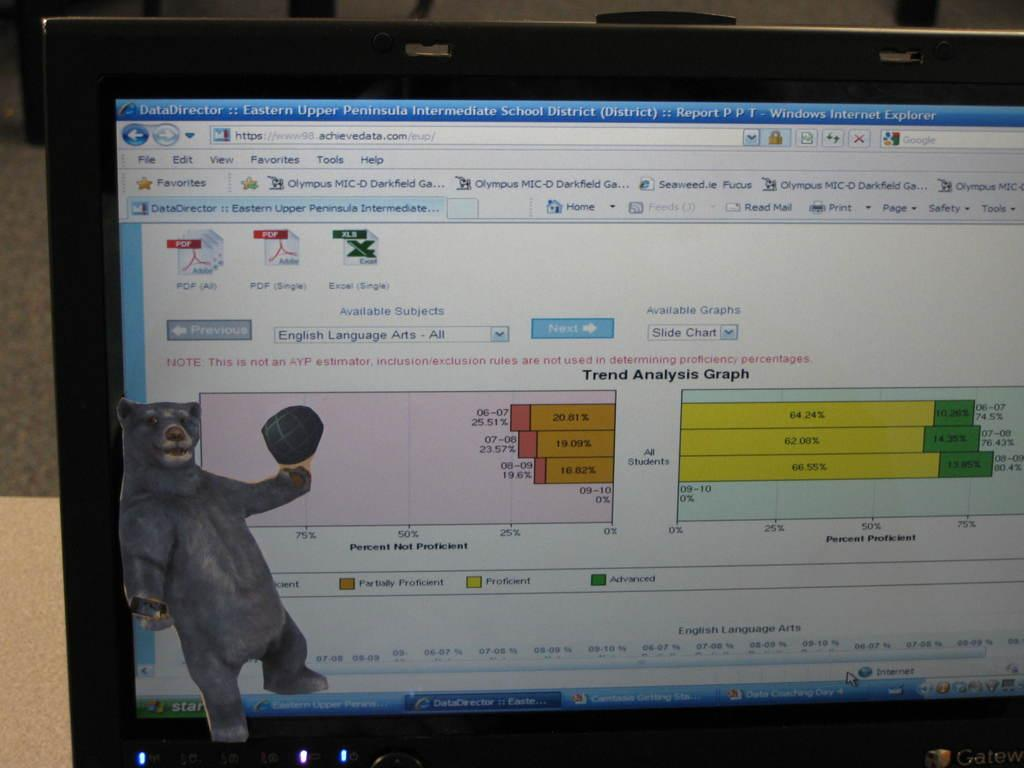<image>
Describe the image concisely. Computer monitor showing a bear and a graph that is titled Trend Analysis Graph. 